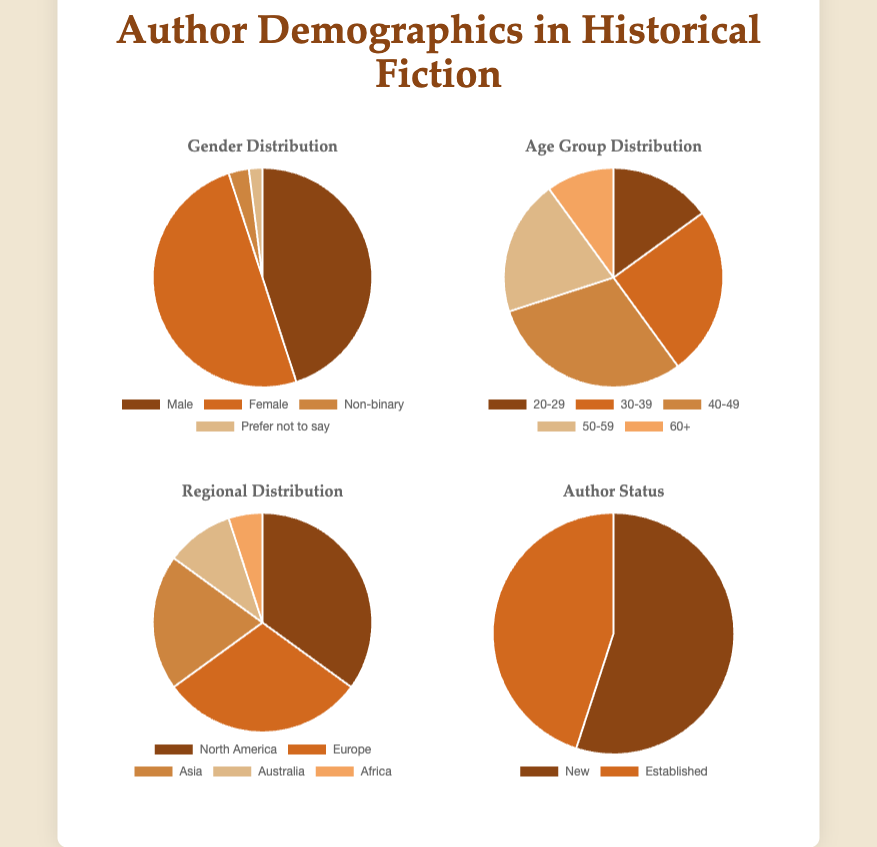What percentage of authors are non-binary or prefer not to say? First, find the total number of authors: 45 (Male) + 50 (Female) + 3 (Non-binary) + 2 (Prefer not to say) = 100. Then, sum the authors who are non-binary or prefer not to say: 3 (Non-binary) + 2 (Prefer not to say) = 5. Finally, calculate the percentage: (5 / 100) * 100% = 5%
Answer: 5% Which gender has the second-largest representation among authors? By comparing the numbers from the data: Male (45), Female (50), Non-binary (3), and Prefer not to say (2), the second-largest is Male with 45 authors.
Answer: Male How many more authors are in the age group 30-39 compared to the group 60+? Find the numbers of authors in the age groups 30-39 and 60+: 30-39 (25) and 60+ (10). Subtract the number in the 60+ group from the 30-39 group: 25 - 10 = 15
Answer: 15 What is the most common region authors are from? From the region data: North America (35), Europe (30), Asia (20), Australia (10), and Africa (5), the most common region is North America with 35 authors.
Answer: North America What fraction of the authors are aged 40-49? The total number of authors, summing all age groups: 20-29 (15) + 30-39 (25) + 40-49 (30) + 50-59 (20) + 60+ (10) = 100. The fraction of authors aged 40-49 is 30/100, which simplifies to 3/10.
Answer: 3/10 Are there more new authors or established authors? By how many? Compare the numbers of new and established authors: New (55) and Established (45). There are 55 - 45 = 10 more new authors than established authors.
Answer: 10 more new authors What proportion of authors are from Europe or Asia? Sum the authors from Europe and Asia: Europe (30) + Asia (20) = 50. The total number of authors is 100. The proportion is 50/100, which simplifies to 1/2 or 50%.
Answer: 50% Which age group has the smallest representation among authors? Comparing the numbers: 20-29 (15), 30-39 (25), 40-49 (30), 50-59 (20), 60+ (10), the smallest age group is 60+ with 10 authors.
Answer: 60+ What is the combined total number of authors from Australia and Africa? Add the number of authors from Australia (10) and Africa (5): 10 + 5 = 15.
Answer: 15 